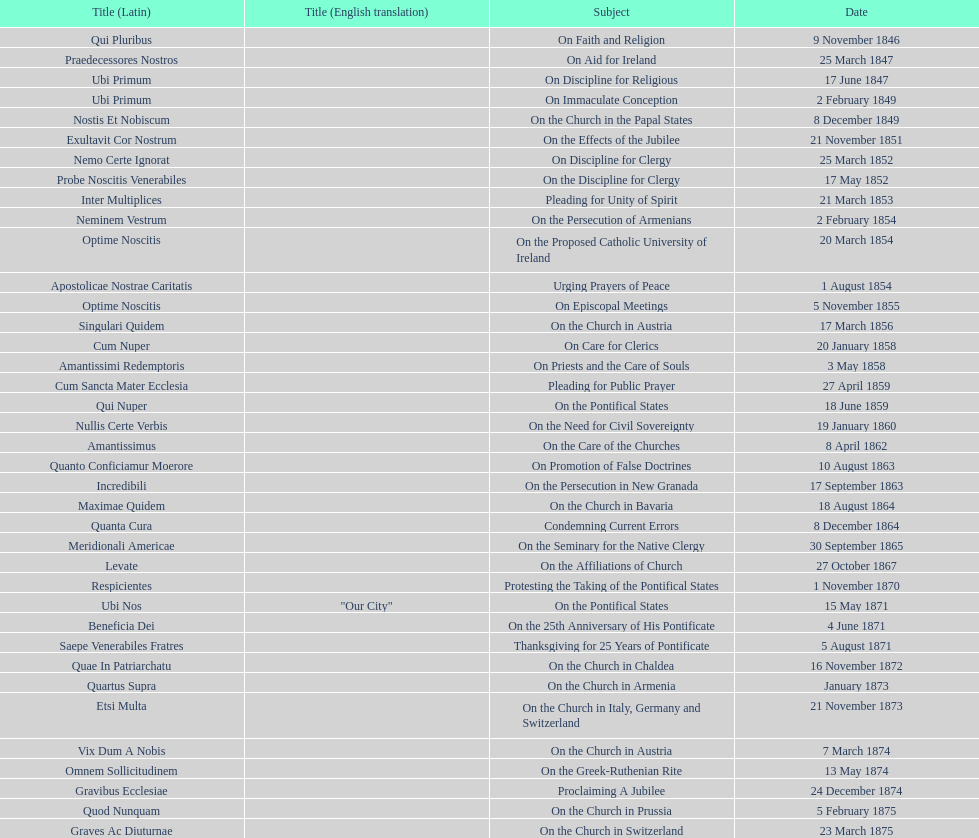Date of the last encyclical whose subject contained the word "pontificate" 5 August 1871. 